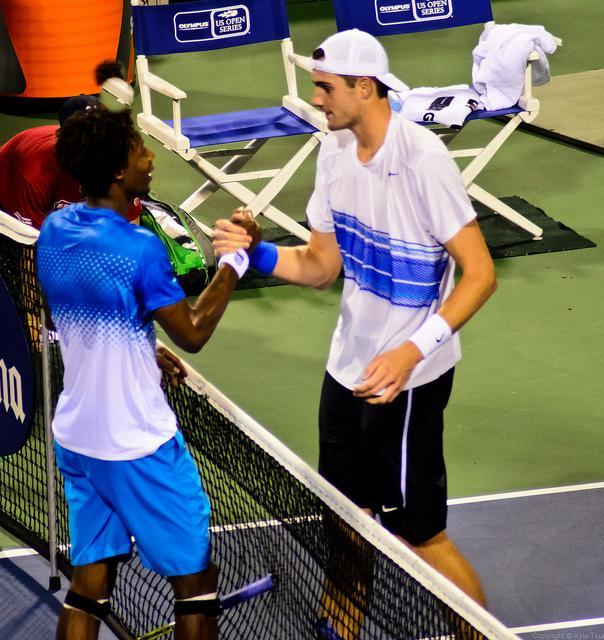Why have the two men gripped hands?

Choices:
A) to swing
B) showing respect
C) arm wrestling
D) to dance showing respect 